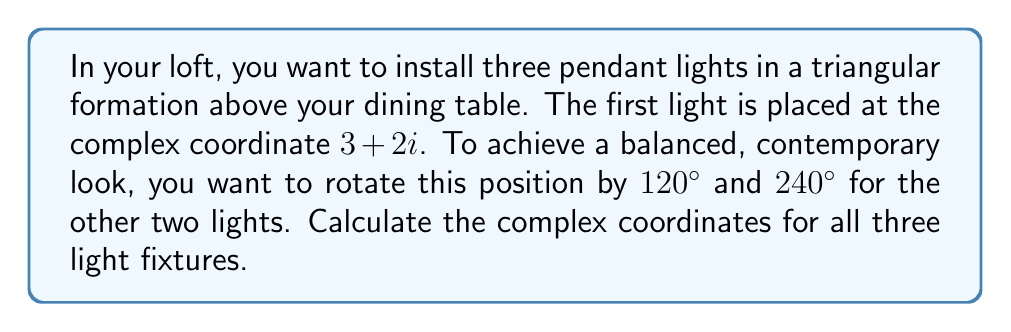Could you help me with this problem? Let's approach this step-by-step:

1) We start with the first light at $z_1 = 3+2i$.

2) To rotate a complex number by an angle $\theta$, we multiply it by $e^{i\theta}$.

3) For $120°$ rotation:
   $\theta = 120° = \frac{2\pi}{3}$ radians
   
   $z_2 = z_1 \cdot e^{i\frac{2\pi}{3}} = (3+2i) \cdot (\cos\frac{2\pi}{3} + i\sin\frac{2\pi}{3})$
   
   $= (3+2i) \cdot (-\frac{1}{2} + i\frac{\sqrt{3}}{2})$
   
   $= (-\frac{3}{2} - \frac{\sqrt{3}}{2}) + i(-\frac{\sqrt{3}}{2} + 1)$

4) For $240°$ rotation:
   $\theta = 240° = \frac{4\pi}{3}$ radians
   
   $z_3 = z_1 \cdot e^{i\frac{4\pi}{3}} = (3+2i) \cdot (\cos\frac{4\pi}{3} + i\sin\frac{4\pi}{3})$
   
   $= (3+2i) \cdot (-\frac{1}{2} - i\frac{\sqrt{3}}{2})$
   
   $= (-\frac{3}{2} + \frac{\sqrt{3}}{2}) + i(\frac{\sqrt{3}}{2} + 1)$

5) Therefore, the three light fixtures will be at:
   $z_1 = 3+2i$
   $z_2 = -\frac{3}{2} - \frac{\sqrt{3}}{2} + i(-\frac{\sqrt{3}}{2} + 1)$
   $z_3 = -\frac{3}{2} + \frac{\sqrt{3}}{2} + i(\frac{\sqrt{3}}{2} + 1)$
Answer: $z_1 = 3+2i$, $z_2 = -\frac{3}{2} - \frac{\sqrt{3}}{2} + i(-\frac{\sqrt{3}}{2} + 1)$, $z_3 = -\frac{3}{2} + \frac{\sqrt{3}}{2} + i(\frac{\sqrt{3}}{2} + 1)$ 